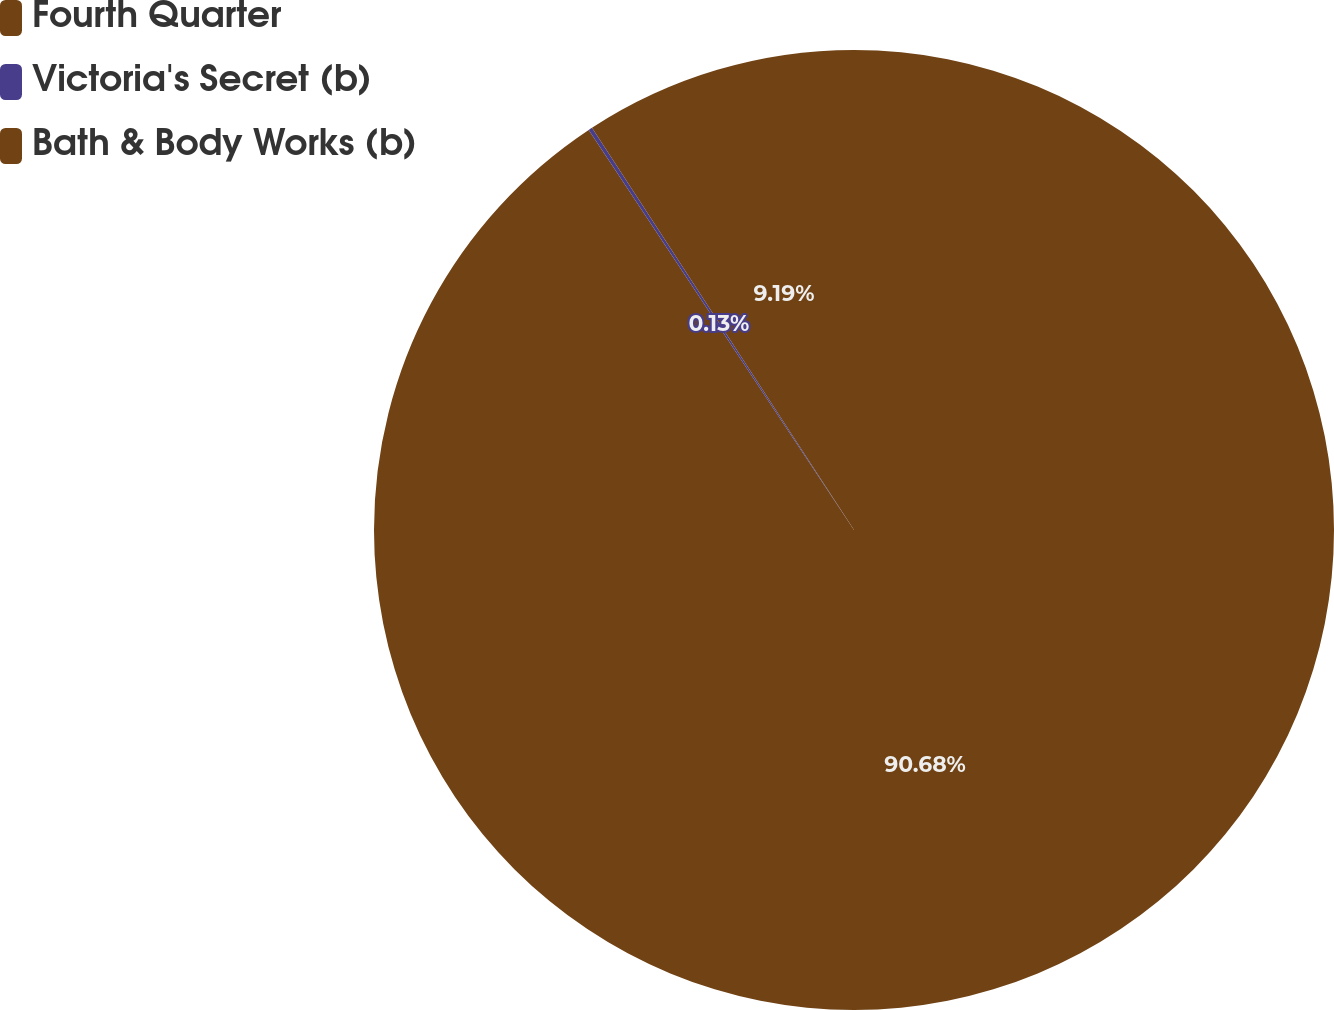Convert chart to OTSL. <chart><loc_0><loc_0><loc_500><loc_500><pie_chart><fcel>Fourth Quarter<fcel>Victoria's Secret (b)<fcel>Bath & Body Works (b)<nl><fcel>90.68%<fcel>0.13%<fcel>9.19%<nl></chart> 